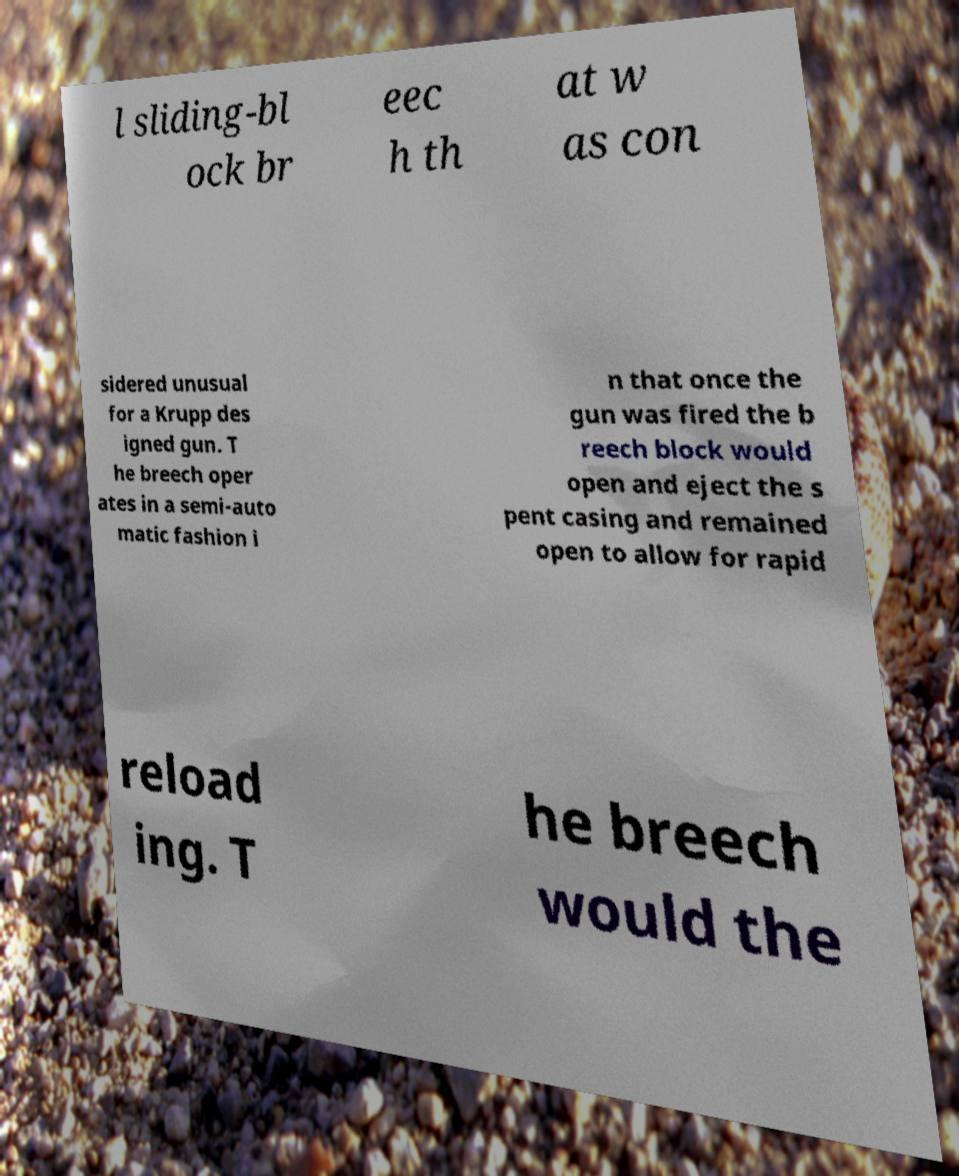I need the written content from this picture converted into text. Can you do that? l sliding-bl ock br eec h th at w as con sidered unusual for a Krupp des igned gun. T he breech oper ates in a semi-auto matic fashion i n that once the gun was fired the b reech block would open and eject the s pent casing and remained open to allow for rapid reload ing. T he breech would the 